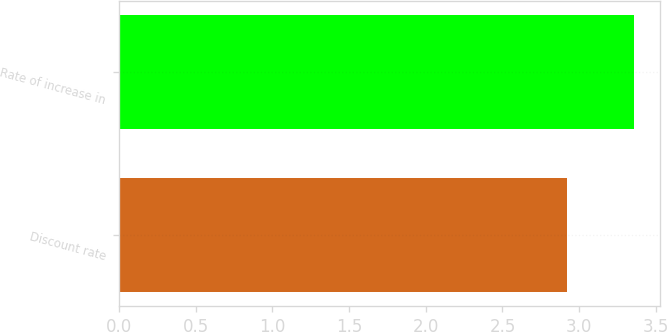Convert chart. <chart><loc_0><loc_0><loc_500><loc_500><bar_chart><fcel>Discount rate<fcel>Rate of increase in<nl><fcel>2.92<fcel>3.36<nl></chart> 